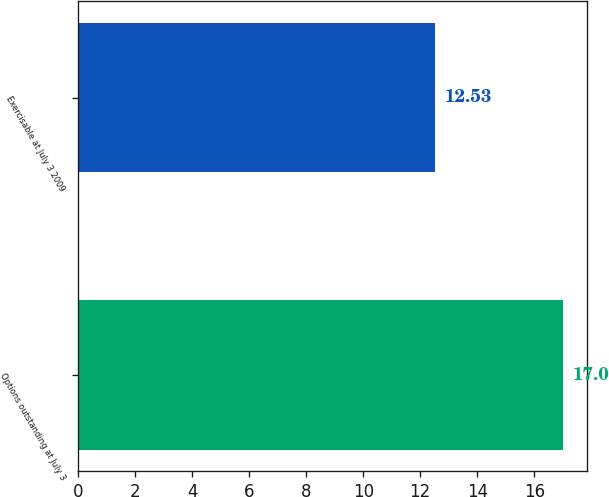Convert chart. <chart><loc_0><loc_0><loc_500><loc_500><bar_chart><fcel>Options outstanding at July 3<fcel>Exercisable at July 3 2009<nl><fcel>17<fcel>12.53<nl></chart> 